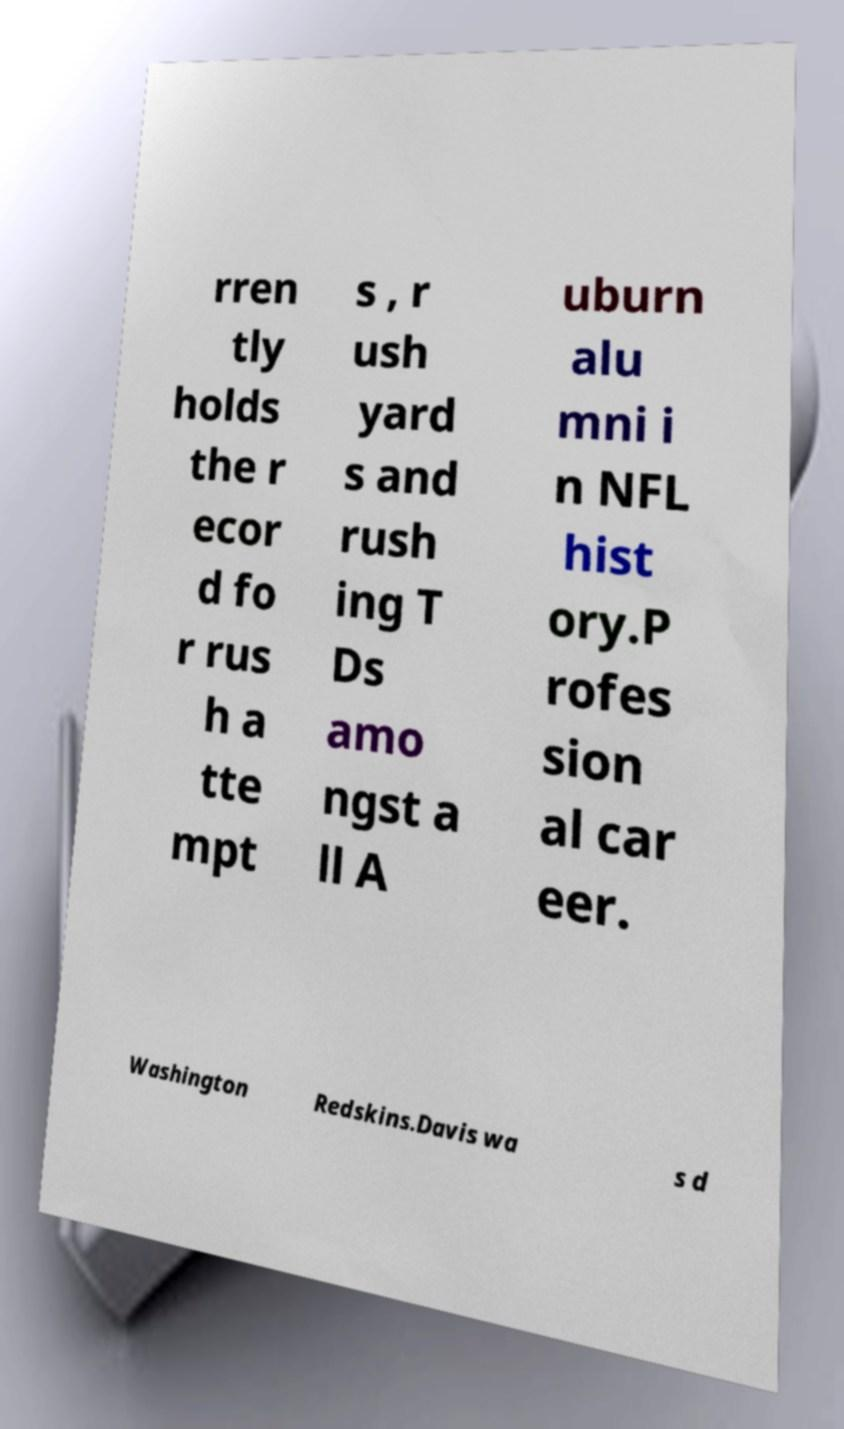I need the written content from this picture converted into text. Can you do that? rren tly holds the r ecor d fo r rus h a tte mpt s , r ush yard s and rush ing T Ds amo ngst a ll A uburn alu mni i n NFL hist ory.P rofes sion al car eer. Washington Redskins.Davis wa s d 